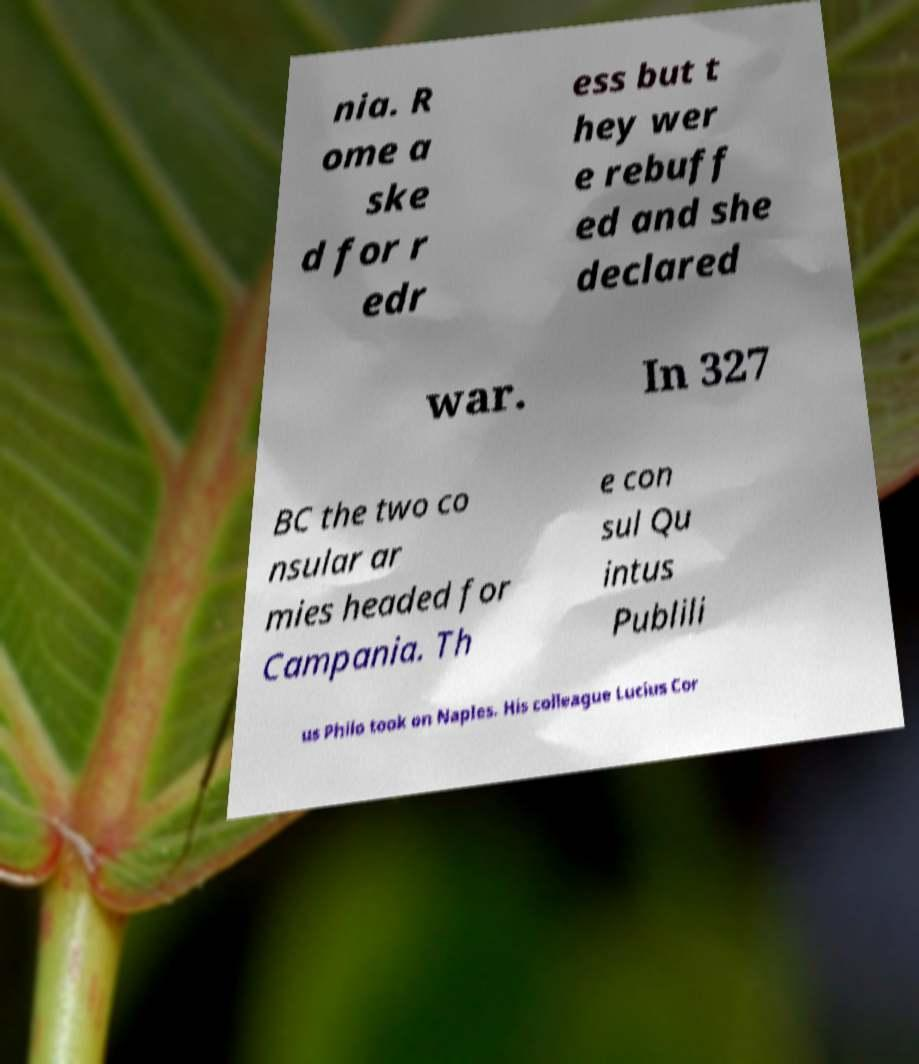Please read and relay the text visible in this image. What does it say? nia. R ome a ske d for r edr ess but t hey wer e rebuff ed and she declared war. In 327 BC the two co nsular ar mies headed for Campania. Th e con sul Qu intus Publili us Philo took on Naples. His colleague Lucius Cor 